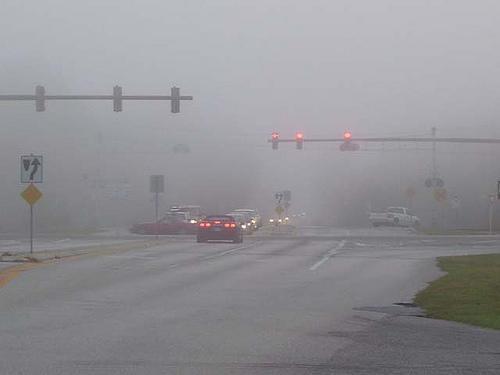How many lanes can turn left?
Give a very brief answer. 1. 